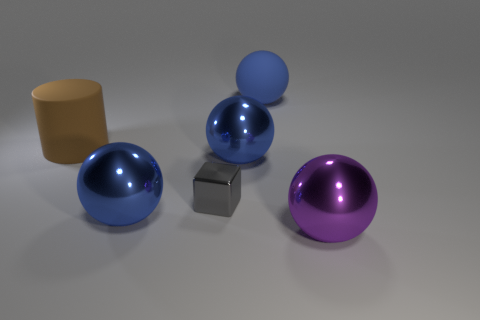Are there any matte spheres to the right of the matte ball?
Give a very brief answer. No. Is there anything else that is the same size as the rubber cylinder?
Your response must be concise. Yes. There is a cube that is the same material as the big purple ball; what is its color?
Make the answer very short. Gray. There is a sphere on the left side of the metallic block; is its color the same as the big matte thing that is right of the rubber cylinder?
Your answer should be very brief. Yes. What number of spheres are big blue rubber things or tiny gray metallic objects?
Make the answer very short. 1. Are there an equal number of purple balls behind the large purple shiny thing and big purple matte cylinders?
Give a very brief answer. Yes. What material is the large blue object on the left side of the blue metallic thing that is behind the blue metallic thing that is on the left side of the gray object?
Offer a terse response. Metal. How many things are large things that are on the right side of the big brown cylinder or big objects?
Your response must be concise. 5. How many things are big green matte cubes or matte objects that are behind the brown matte cylinder?
Keep it short and to the point. 1. How many small gray metal things are in front of the thing that is on the right side of the blue rubber sphere right of the small metal block?
Keep it short and to the point. 0. 